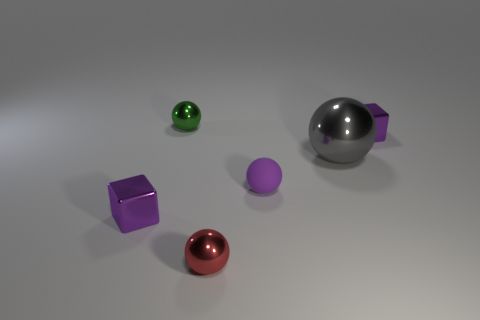Is there anything else that is made of the same material as the small purple ball?
Offer a terse response. No. How many small red things are behind the small purple thing that is to the left of the ball that is on the left side of the small red shiny sphere?
Provide a succinct answer. 0. Are there the same number of tiny metal objects that are right of the matte object and purple things left of the red object?
Provide a short and direct response. Yes. What number of tiny red shiny objects have the same shape as the purple rubber object?
Give a very brief answer. 1. Is there a large gray cylinder that has the same material as the small green object?
Offer a very short reply. No. How many big red matte blocks are there?
Provide a succinct answer. 0. What number of balls are purple rubber things or red metal things?
Your response must be concise. 2. There is a rubber ball that is the same size as the red metal object; what is its color?
Provide a succinct answer. Purple. What number of objects are both to the left of the large metallic sphere and behind the big gray thing?
Provide a short and direct response. 1. What is the material of the tiny green thing?
Keep it short and to the point. Metal. 